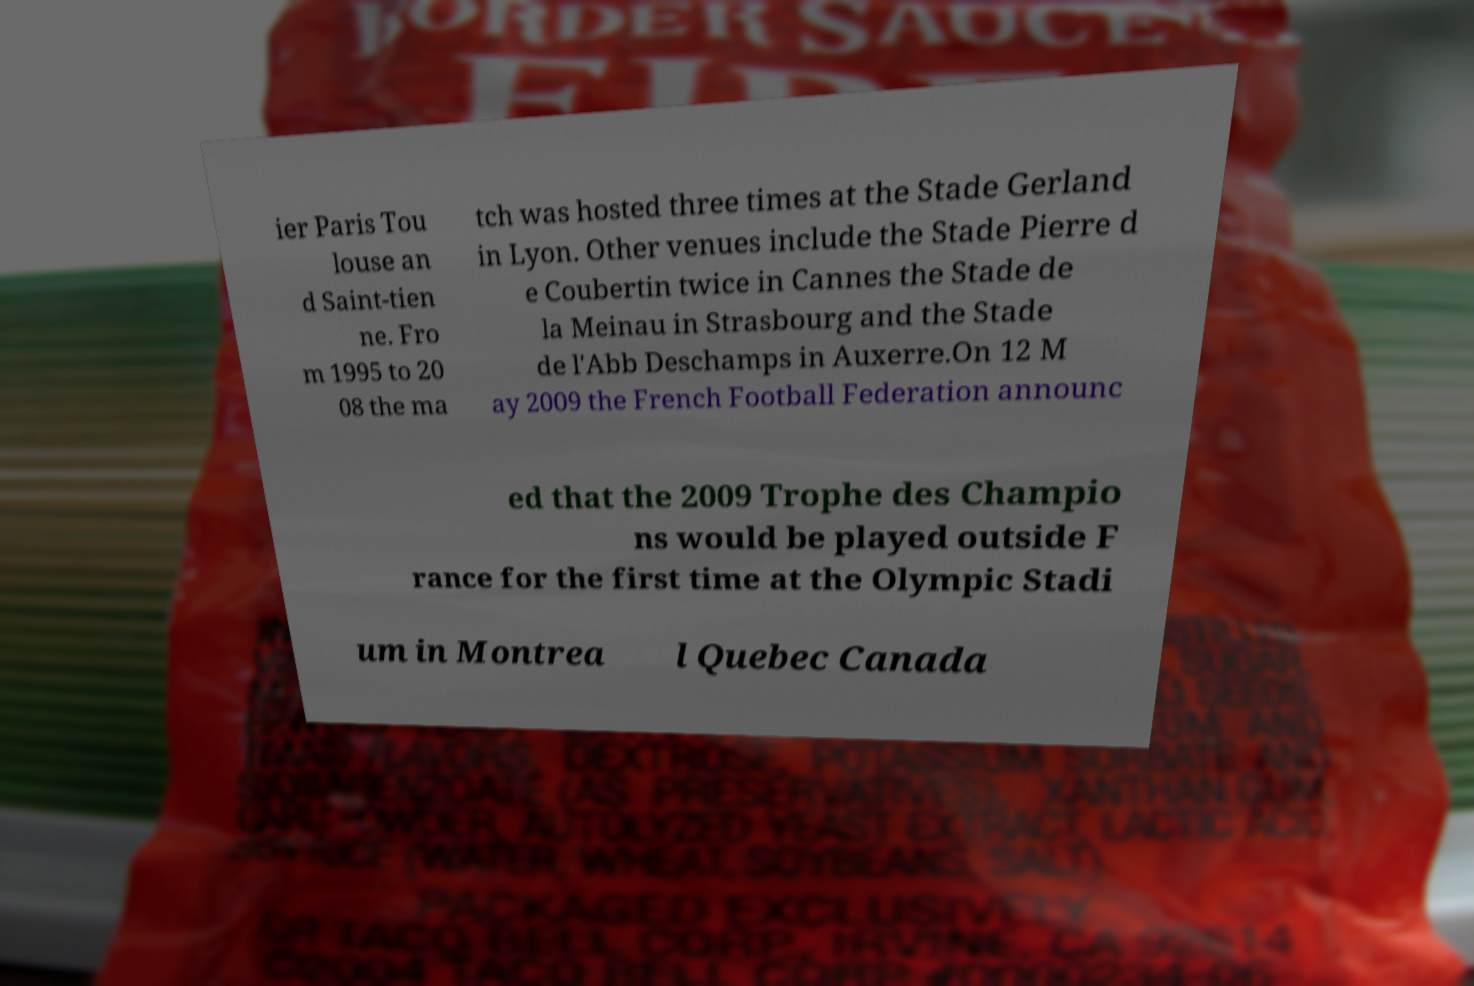Could you extract and type out the text from this image? ier Paris Tou louse an d Saint-tien ne. Fro m 1995 to 20 08 the ma tch was hosted three times at the Stade Gerland in Lyon. Other venues include the Stade Pierre d e Coubertin twice in Cannes the Stade de la Meinau in Strasbourg and the Stade de l'Abb Deschamps in Auxerre.On 12 M ay 2009 the French Football Federation announc ed that the 2009 Trophe des Champio ns would be played outside F rance for the first time at the Olympic Stadi um in Montrea l Quebec Canada 